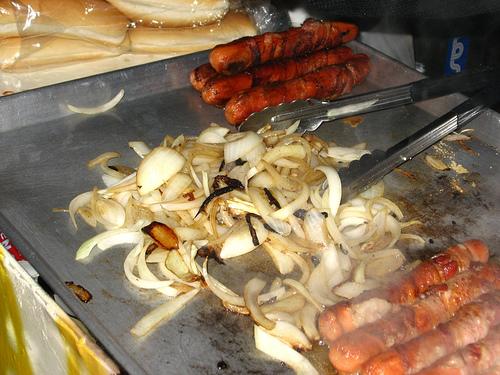How many sausages are being cooked?
Keep it brief. 4. What cuisine is being grilled?
Give a very brief answer. Hot dogs and onions. How many onions fried onions are on the tray?
Write a very short answer. 100. 